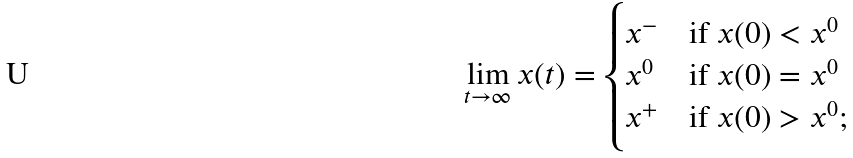Convert formula to latex. <formula><loc_0><loc_0><loc_500><loc_500>\lim _ { t \to \infty } x ( t ) = \begin{cases} x ^ { - } & \text {if $x(0)<x^{0}$} \\ x ^ { 0 } & \text {if $x(0)=x^{0}$} \\ x ^ { + } & \text {if $x(0)>x^{0}$;} \end{cases}</formula> 